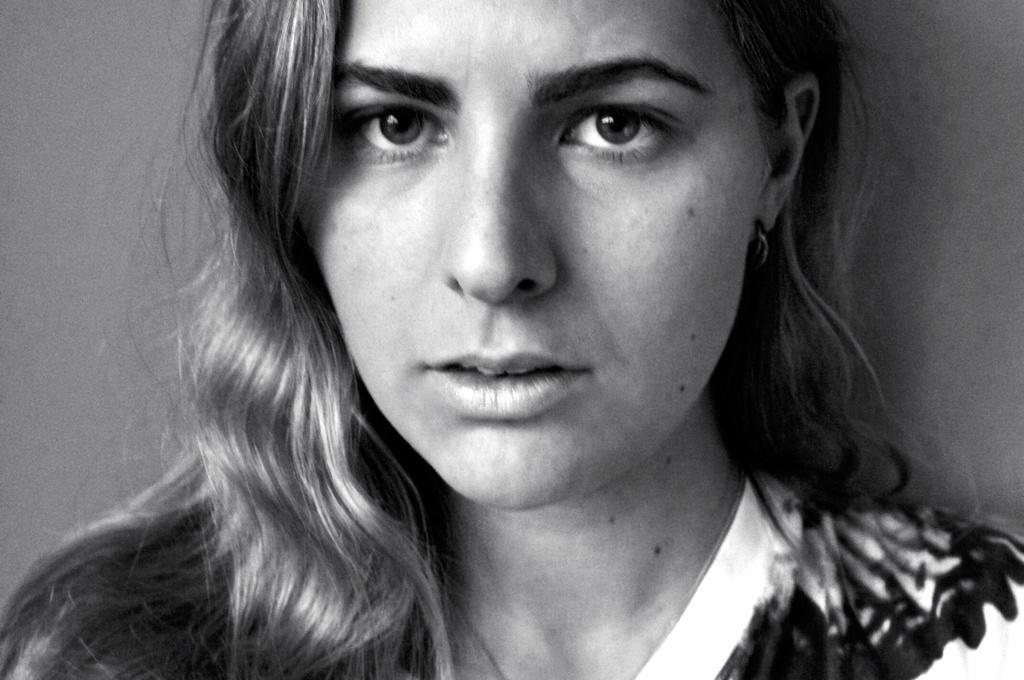Could you give a brief overview of what you see in this image? In the picture we can see a woman face and on her face we can see some moles till her neck and in the background we can see a wall and it is a black and white photography. 